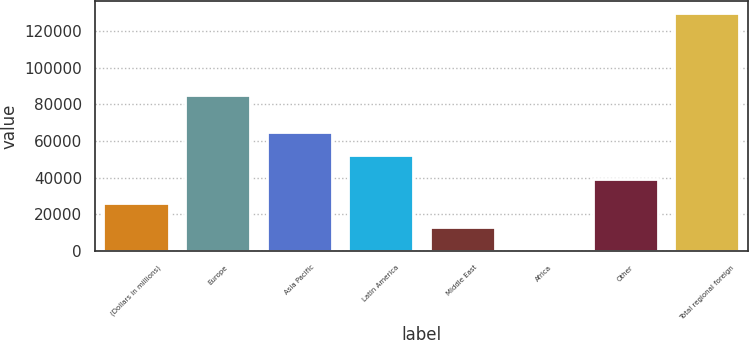Convert chart. <chart><loc_0><loc_0><loc_500><loc_500><bar_chart><fcel>(Dollars in millions)<fcel>Europe<fcel>Asia Pacific<fcel>Latin America<fcel>Middle East<fcel>Africa<fcel>Other<fcel>Total regional foreign<nl><fcel>26241.4<fcel>85279<fcel>65128<fcel>52165.8<fcel>13279.2<fcel>317<fcel>39203.6<fcel>129939<nl></chart> 